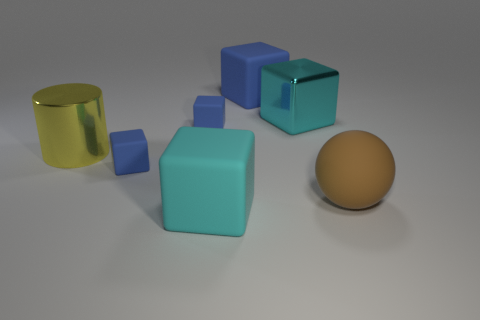Can you tell me about the colors of the objects in the image? Certainly! The image showcases objects with three distinct colors. There are three blue objects that have a light shade of blue, one object that is golden yellow, and one that has a matte brown finish. 